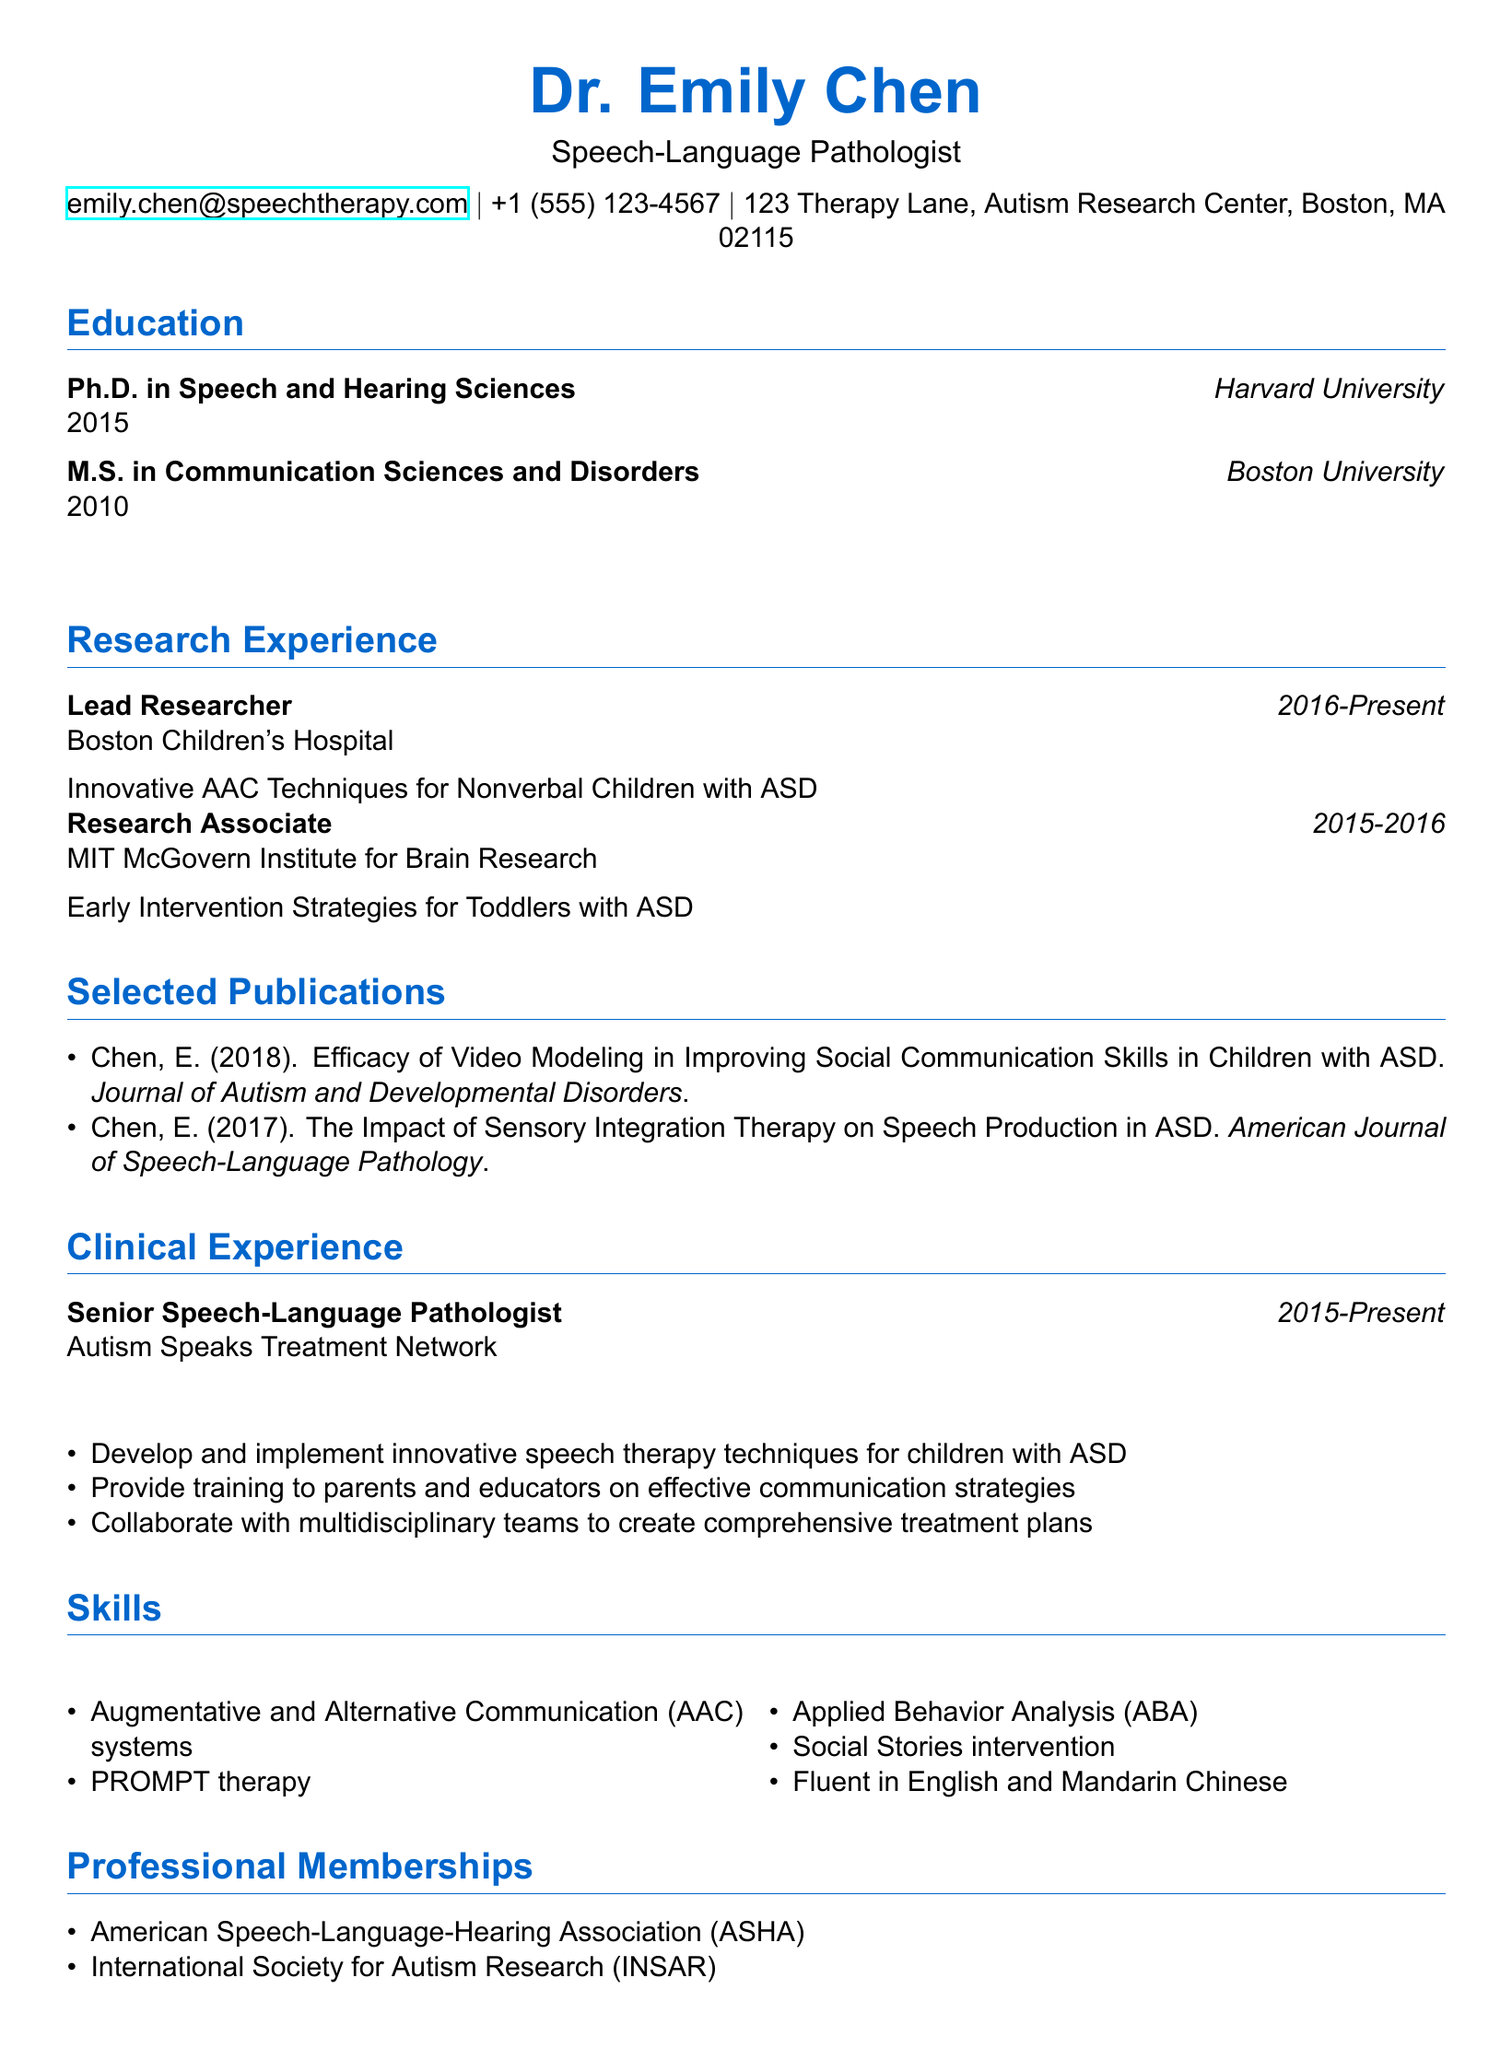what is the name of the individual in this CV? The name is explicitly stated at the top of the CV, identifying the individual.
Answer: Dr. Emily Chen what is the highest degree attained by Dr. Emily Chen? The highest degree is mentioned in the education section of the CV.
Answer: Ph.D. in Speech and Hearing Sciences where is Dr. Emily Chen currently employed? The current employment is listed under clinical experience in the CV.
Answer: Autism Speaks Treatment Network how many years has Dr. Emily Chen worked as a Lead Researcher? The duration as Lead Researcher can be calculated from the dates mentioned in the research experience section.
Answer: 7 years which therapy technique is Dr. Chen skilled in that involves visual aids? The skills section mentions specific therapeutic approaches, including the use of visual supports.
Answer: AAC systems what is one of the primary responsibilities of Dr. Chen as a Senior Speech-Language Pathologist? The CV highlights several responsibilities in the clinical experience section.
Answer: Develop and implement innovative speech therapy techniques for children with ASD which organization is Dr. Chen a member of that relates to speech-language pathology? The professional memberships section indicates membership details.
Answer: American Speech-Language-Hearing Association (ASHA) in what year was Dr. Chen's publication on video modeling released? The publication details include the year of release in the selected publications section.
Answer: 2018 what type of research project did Dr. Chen work on at MIT? The project title gives insight into the nature of the research conducted during this period.
Answer: Early Intervention Strategies for Toddlers with ASD 